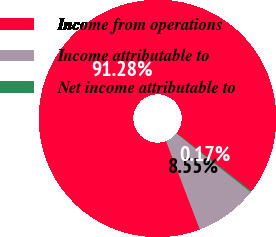<chart> <loc_0><loc_0><loc_500><loc_500><pie_chart><fcel>Income from operations<fcel>Income attributable to<fcel>Net income attributable to<nl><fcel>91.27%<fcel>8.55%<fcel>0.17%<nl></chart> 